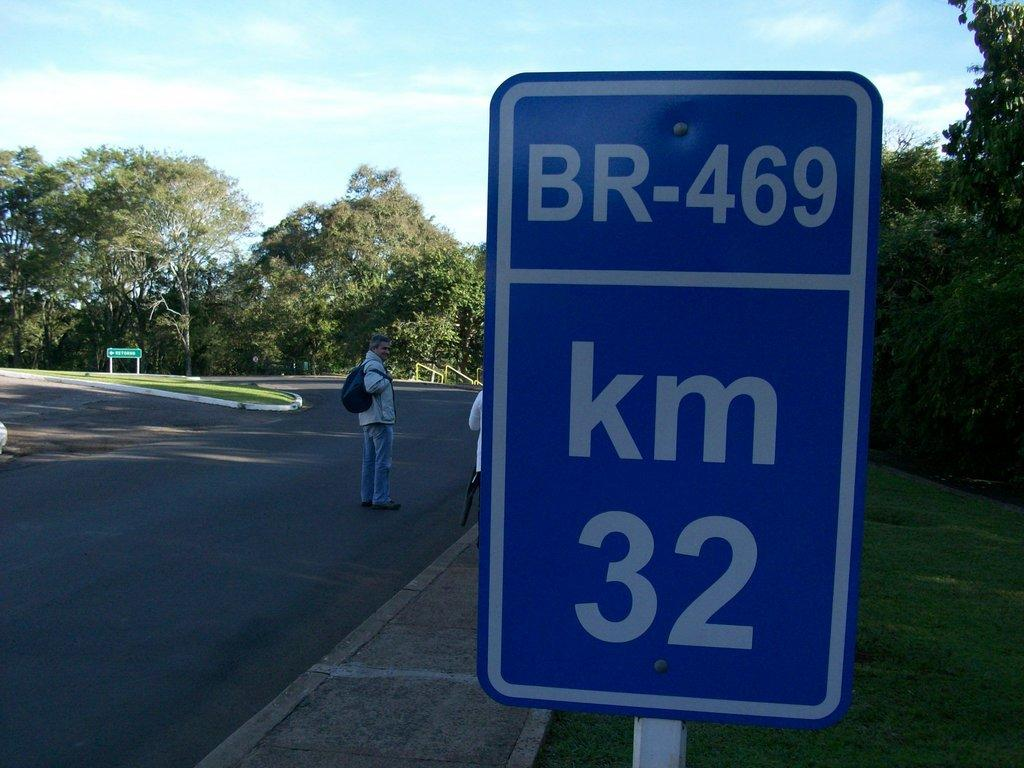<image>
Create a compact narrative representing the image presented. A blue sign on the side of the road says BR-469 km 32. 